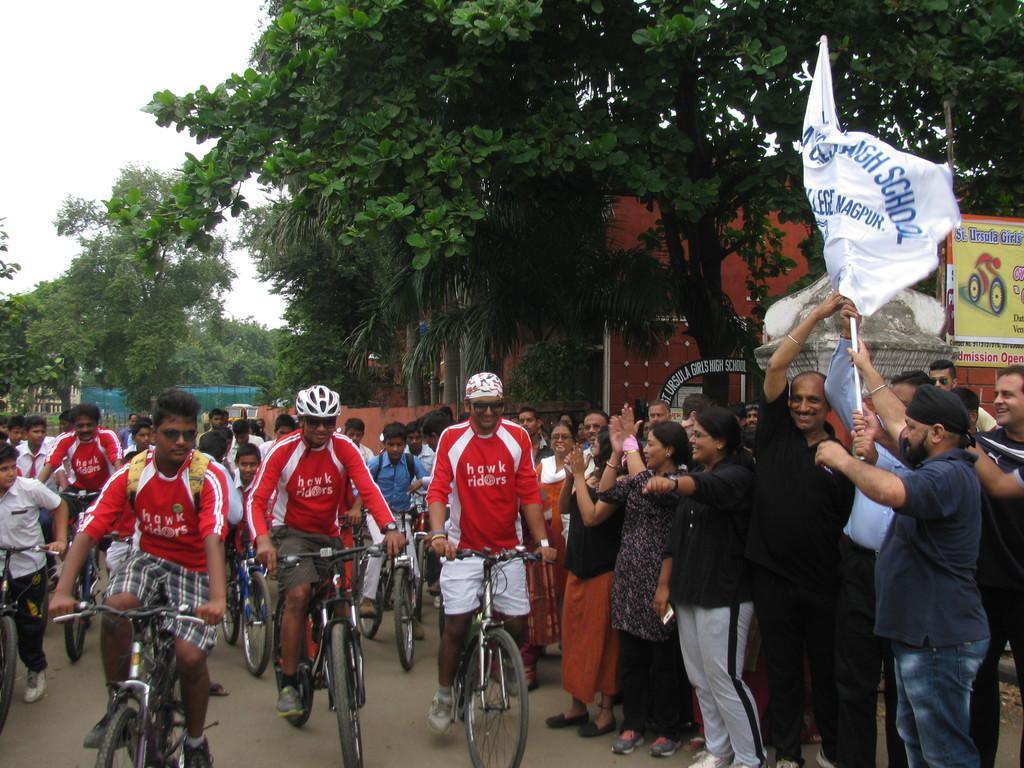Please provide a concise description of this image. This image is taken in outdoors. There are many people in this image. In the middle of the image few people are riding a bicycle wearing helmet. In the bottom of the image there is a road. In the right side of the image there are many people standing and holding a flag in their hands. At the top of the image there are many trees, there is a sky. 